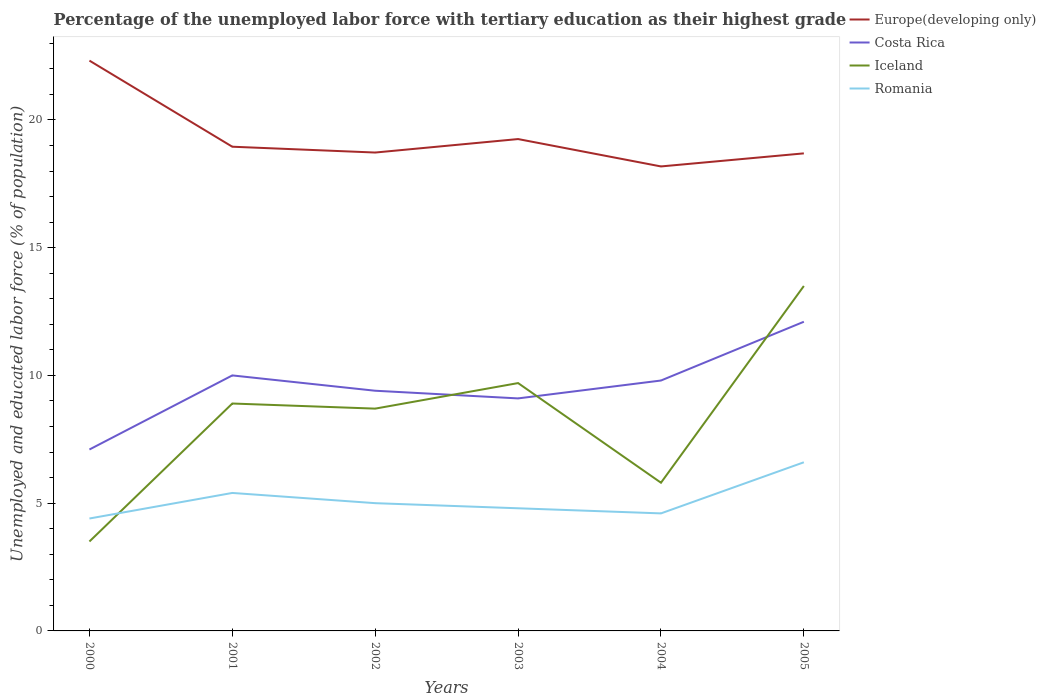How many different coloured lines are there?
Offer a very short reply. 4. Across all years, what is the maximum percentage of the unemployed labor force with tertiary education in Romania?
Your response must be concise. 4.4. What is the total percentage of the unemployed labor force with tertiary education in Iceland in the graph?
Your answer should be very brief. -1. What is the difference between the highest and the second highest percentage of the unemployed labor force with tertiary education in Romania?
Your answer should be very brief. 2.2. Is the percentage of the unemployed labor force with tertiary education in Europe(developing only) strictly greater than the percentage of the unemployed labor force with tertiary education in Romania over the years?
Provide a short and direct response. No. What is the difference between two consecutive major ticks on the Y-axis?
Keep it short and to the point. 5. How many legend labels are there?
Keep it short and to the point. 4. What is the title of the graph?
Ensure brevity in your answer.  Percentage of the unemployed labor force with tertiary education as their highest grade. Does "Cambodia" appear as one of the legend labels in the graph?
Provide a short and direct response. No. What is the label or title of the Y-axis?
Your answer should be very brief. Unemployed and educated labor force (% of population). What is the Unemployed and educated labor force (% of population) in Europe(developing only) in 2000?
Your answer should be compact. 22.32. What is the Unemployed and educated labor force (% of population) of Costa Rica in 2000?
Ensure brevity in your answer.  7.1. What is the Unemployed and educated labor force (% of population) in Romania in 2000?
Your answer should be very brief. 4.4. What is the Unemployed and educated labor force (% of population) in Europe(developing only) in 2001?
Ensure brevity in your answer.  18.95. What is the Unemployed and educated labor force (% of population) in Iceland in 2001?
Provide a short and direct response. 8.9. What is the Unemployed and educated labor force (% of population) of Romania in 2001?
Provide a succinct answer. 5.4. What is the Unemployed and educated labor force (% of population) in Europe(developing only) in 2002?
Ensure brevity in your answer.  18.72. What is the Unemployed and educated labor force (% of population) of Costa Rica in 2002?
Ensure brevity in your answer.  9.4. What is the Unemployed and educated labor force (% of population) in Iceland in 2002?
Provide a succinct answer. 8.7. What is the Unemployed and educated labor force (% of population) in Romania in 2002?
Ensure brevity in your answer.  5. What is the Unemployed and educated labor force (% of population) of Europe(developing only) in 2003?
Your response must be concise. 19.25. What is the Unemployed and educated labor force (% of population) of Costa Rica in 2003?
Offer a terse response. 9.1. What is the Unemployed and educated labor force (% of population) in Iceland in 2003?
Offer a very short reply. 9.7. What is the Unemployed and educated labor force (% of population) in Romania in 2003?
Offer a terse response. 4.8. What is the Unemployed and educated labor force (% of population) in Europe(developing only) in 2004?
Make the answer very short. 18.18. What is the Unemployed and educated labor force (% of population) in Costa Rica in 2004?
Offer a very short reply. 9.8. What is the Unemployed and educated labor force (% of population) in Iceland in 2004?
Keep it short and to the point. 5.8. What is the Unemployed and educated labor force (% of population) in Romania in 2004?
Your answer should be compact. 4.6. What is the Unemployed and educated labor force (% of population) in Europe(developing only) in 2005?
Provide a succinct answer. 18.69. What is the Unemployed and educated labor force (% of population) of Costa Rica in 2005?
Ensure brevity in your answer.  12.1. What is the Unemployed and educated labor force (% of population) in Iceland in 2005?
Offer a terse response. 13.5. What is the Unemployed and educated labor force (% of population) in Romania in 2005?
Your response must be concise. 6.6. Across all years, what is the maximum Unemployed and educated labor force (% of population) in Europe(developing only)?
Provide a short and direct response. 22.32. Across all years, what is the maximum Unemployed and educated labor force (% of population) of Costa Rica?
Your response must be concise. 12.1. Across all years, what is the maximum Unemployed and educated labor force (% of population) in Romania?
Provide a short and direct response. 6.6. Across all years, what is the minimum Unemployed and educated labor force (% of population) of Europe(developing only)?
Offer a terse response. 18.18. Across all years, what is the minimum Unemployed and educated labor force (% of population) in Costa Rica?
Your answer should be compact. 7.1. Across all years, what is the minimum Unemployed and educated labor force (% of population) in Romania?
Ensure brevity in your answer.  4.4. What is the total Unemployed and educated labor force (% of population) of Europe(developing only) in the graph?
Provide a succinct answer. 116.11. What is the total Unemployed and educated labor force (% of population) of Costa Rica in the graph?
Your response must be concise. 57.5. What is the total Unemployed and educated labor force (% of population) in Iceland in the graph?
Keep it short and to the point. 50.1. What is the total Unemployed and educated labor force (% of population) of Romania in the graph?
Make the answer very short. 30.8. What is the difference between the Unemployed and educated labor force (% of population) in Europe(developing only) in 2000 and that in 2001?
Provide a short and direct response. 3.37. What is the difference between the Unemployed and educated labor force (% of population) of Costa Rica in 2000 and that in 2001?
Give a very brief answer. -2.9. What is the difference between the Unemployed and educated labor force (% of population) of Romania in 2000 and that in 2001?
Your answer should be compact. -1. What is the difference between the Unemployed and educated labor force (% of population) in Europe(developing only) in 2000 and that in 2002?
Provide a short and direct response. 3.6. What is the difference between the Unemployed and educated labor force (% of population) in Costa Rica in 2000 and that in 2002?
Provide a succinct answer. -2.3. What is the difference between the Unemployed and educated labor force (% of population) of Europe(developing only) in 2000 and that in 2003?
Provide a short and direct response. 3.07. What is the difference between the Unemployed and educated labor force (% of population) of Iceland in 2000 and that in 2003?
Give a very brief answer. -6.2. What is the difference between the Unemployed and educated labor force (% of population) in Europe(developing only) in 2000 and that in 2004?
Give a very brief answer. 4.14. What is the difference between the Unemployed and educated labor force (% of population) in Costa Rica in 2000 and that in 2004?
Offer a terse response. -2.7. What is the difference between the Unemployed and educated labor force (% of population) of Romania in 2000 and that in 2004?
Your answer should be compact. -0.2. What is the difference between the Unemployed and educated labor force (% of population) in Europe(developing only) in 2000 and that in 2005?
Provide a short and direct response. 3.63. What is the difference between the Unemployed and educated labor force (% of population) of Costa Rica in 2000 and that in 2005?
Provide a short and direct response. -5. What is the difference between the Unemployed and educated labor force (% of population) of Iceland in 2000 and that in 2005?
Give a very brief answer. -10. What is the difference between the Unemployed and educated labor force (% of population) in Romania in 2000 and that in 2005?
Offer a terse response. -2.2. What is the difference between the Unemployed and educated labor force (% of population) of Europe(developing only) in 2001 and that in 2002?
Your answer should be very brief. 0.23. What is the difference between the Unemployed and educated labor force (% of population) in Costa Rica in 2001 and that in 2002?
Give a very brief answer. 0.6. What is the difference between the Unemployed and educated labor force (% of population) of Iceland in 2001 and that in 2002?
Your response must be concise. 0.2. What is the difference between the Unemployed and educated labor force (% of population) in Romania in 2001 and that in 2002?
Your answer should be very brief. 0.4. What is the difference between the Unemployed and educated labor force (% of population) in Europe(developing only) in 2001 and that in 2003?
Offer a very short reply. -0.3. What is the difference between the Unemployed and educated labor force (% of population) of Costa Rica in 2001 and that in 2003?
Your answer should be very brief. 0.9. What is the difference between the Unemployed and educated labor force (% of population) in Romania in 2001 and that in 2003?
Your answer should be very brief. 0.6. What is the difference between the Unemployed and educated labor force (% of population) of Europe(developing only) in 2001 and that in 2004?
Your answer should be compact. 0.77. What is the difference between the Unemployed and educated labor force (% of population) in Costa Rica in 2001 and that in 2004?
Provide a succinct answer. 0.2. What is the difference between the Unemployed and educated labor force (% of population) in Iceland in 2001 and that in 2004?
Make the answer very short. 3.1. What is the difference between the Unemployed and educated labor force (% of population) in Romania in 2001 and that in 2004?
Your response must be concise. 0.8. What is the difference between the Unemployed and educated labor force (% of population) of Europe(developing only) in 2001 and that in 2005?
Provide a short and direct response. 0.26. What is the difference between the Unemployed and educated labor force (% of population) in Iceland in 2001 and that in 2005?
Your answer should be very brief. -4.6. What is the difference between the Unemployed and educated labor force (% of population) in Romania in 2001 and that in 2005?
Your answer should be compact. -1.2. What is the difference between the Unemployed and educated labor force (% of population) of Europe(developing only) in 2002 and that in 2003?
Keep it short and to the point. -0.53. What is the difference between the Unemployed and educated labor force (% of population) in Europe(developing only) in 2002 and that in 2004?
Keep it short and to the point. 0.54. What is the difference between the Unemployed and educated labor force (% of population) of Europe(developing only) in 2002 and that in 2005?
Offer a terse response. 0.03. What is the difference between the Unemployed and educated labor force (% of population) of Iceland in 2002 and that in 2005?
Your answer should be compact. -4.8. What is the difference between the Unemployed and educated labor force (% of population) of Romania in 2002 and that in 2005?
Your answer should be very brief. -1.6. What is the difference between the Unemployed and educated labor force (% of population) of Europe(developing only) in 2003 and that in 2004?
Provide a short and direct response. 1.07. What is the difference between the Unemployed and educated labor force (% of population) of Costa Rica in 2003 and that in 2004?
Your answer should be very brief. -0.7. What is the difference between the Unemployed and educated labor force (% of population) of Iceland in 2003 and that in 2004?
Ensure brevity in your answer.  3.9. What is the difference between the Unemployed and educated labor force (% of population) in Europe(developing only) in 2003 and that in 2005?
Provide a short and direct response. 0.56. What is the difference between the Unemployed and educated labor force (% of population) of Costa Rica in 2003 and that in 2005?
Provide a succinct answer. -3. What is the difference between the Unemployed and educated labor force (% of population) in Romania in 2003 and that in 2005?
Your answer should be compact. -1.8. What is the difference between the Unemployed and educated labor force (% of population) of Europe(developing only) in 2004 and that in 2005?
Give a very brief answer. -0.51. What is the difference between the Unemployed and educated labor force (% of population) of Iceland in 2004 and that in 2005?
Provide a short and direct response. -7.7. What is the difference between the Unemployed and educated labor force (% of population) in Europe(developing only) in 2000 and the Unemployed and educated labor force (% of population) in Costa Rica in 2001?
Give a very brief answer. 12.32. What is the difference between the Unemployed and educated labor force (% of population) of Europe(developing only) in 2000 and the Unemployed and educated labor force (% of population) of Iceland in 2001?
Provide a short and direct response. 13.42. What is the difference between the Unemployed and educated labor force (% of population) in Europe(developing only) in 2000 and the Unemployed and educated labor force (% of population) in Romania in 2001?
Offer a very short reply. 16.92. What is the difference between the Unemployed and educated labor force (% of population) of Costa Rica in 2000 and the Unemployed and educated labor force (% of population) of Romania in 2001?
Your answer should be compact. 1.7. What is the difference between the Unemployed and educated labor force (% of population) in Europe(developing only) in 2000 and the Unemployed and educated labor force (% of population) in Costa Rica in 2002?
Offer a very short reply. 12.92. What is the difference between the Unemployed and educated labor force (% of population) in Europe(developing only) in 2000 and the Unemployed and educated labor force (% of population) in Iceland in 2002?
Offer a very short reply. 13.62. What is the difference between the Unemployed and educated labor force (% of population) of Europe(developing only) in 2000 and the Unemployed and educated labor force (% of population) of Romania in 2002?
Provide a succinct answer. 17.32. What is the difference between the Unemployed and educated labor force (% of population) in Costa Rica in 2000 and the Unemployed and educated labor force (% of population) in Iceland in 2002?
Your answer should be compact. -1.6. What is the difference between the Unemployed and educated labor force (% of population) in Costa Rica in 2000 and the Unemployed and educated labor force (% of population) in Romania in 2002?
Your answer should be very brief. 2.1. What is the difference between the Unemployed and educated labor force (% of population) of Iceland in 2000 and the Unemployed and educated labor force (% of population) of Romania in 2002?
Offer a terse response. -1.5. What is the difference between the Unemployed and educated labor force (% of population) in Europe(developing only) in 2000 and the Unemployed and educated labor force (% of population) in Costa Rica in 2003?
Offer a terse response. 13.22. What is the difference between the Unemployed and educated labor force (% of population) in Europe(developing only) in 2000 and the Unemployed and educated labor force (% of population) in Iceland in 2003?
Offer a very short reply. 12.62. What is the difference between the Unemployed and educated labor force (% of population) in Europe(developing only) in 2000 and the Unemployed and educated labor force (% of population) in Romania in 2003?
Make the answer very short. 17.52. What is the difference between the Unemployed and educated labor force (% of population) in Costa Rica in 2000 and the Unemployed and educated labor force (% of population) in Iceland in 2003?
Provide a short and direct response. -2.6. What is the difference between the Unemployed and educated labor force (% of population) of Costa Rica in 2000 and the Unemployed and educated labor force (% of population) of Romania in 2003?
Your answer should be very brief. 2.3. What is the difference between the Unemployed and educated labor force (% of population) in Iceland in 2000 and the Unemployed and educated labor force (% of population) in Romania in 2003?
Your response must be concise. -1.3. What is the difference between the Unemployed and educated labor force (% of population) in Europe(developing only) in 2000 and the Unemployed and educated labor force (% of population) in Costa Rica in 2004?
Your answer should be compact. 12.52. What is the difference between the Unemployed and educated labor force (% of population) of Europe(developing only) in 2000 and the Unemployed and educated labor force (% of population) of Iceland in 2004?
Keep it short and to the point. 16.52. What is the difference between the Unemployed and educated labor force (% of population) of Europe(developing only) in 2000 and the Unemployed and educated labor force (% of population) of Romania in 2004?
Give a very brief answer. 17.72. What is the difference between the Unemployed and educated labor force (% of population) in Costa Rica in 2000 and the Unemployed and educated labor force (% of population) in Iceland in 2004?
Ensure brevity in your answer.  1.3. What is the difference between the Unemployed and educated labor force (% of population) of Iceland in 2000 and the Unemployed and educated labor force (% of population) of Romania in 2004?
Ensure brevity in your answer.  -1.1. What is the difference between the Unemployed and educated labor force (% of population) in Europe(developing only) in 2000 and the Unemployed and educated labor force (% of population) in Costa Rica in 2005?
Provide a short and direct response. 10.22. What is the difference between the Unemployed and educated labor force (% of population) in Europe(developing only) in 2000 and the Unemployed and educated labor force (% of population) in Iceland in 2005?
Make the answer very short. 8.82. What is the difference between the Unemployed and educated labor force (% of population) of Europe(developing only) in 2000 and the Unemployed and educated labor force (% of population) of Romania in 2005?
Offer a terse response. 15.72. What is the difference between the Unemployed and educated labor force (% of population) in Costa Rica in 2000 and the Unemployed and educated labor force (% of population) in Iceland in 2005?
Your answer should be compact. -6.4. What is the difference between the Unemployed and educated labor force (% of population) in Iceland in 2000 and the Unemployed and educated labor force (% of population) in Romania in 2005?
Give a very brief answer. -3.1. What is the difference between the Unemployed and educated labor force (% of population) in Europe(developing only) in 2001 and the Unemployed and educated labor force (% of population) in Costa Rica in 2002?
Provide a short and direct response. 9.55. What is the difference between the Unemployed and educated labor force (% of population) in Europe(developing only) in 2001 and the Unemployed and educated labor force (% of population) in Iceland in 2002?
Offer a very short reply. 10.25. What is the difference between the Unemployed and educated labor force (% of population) in Europe(developing only) in 2001 and the Unemployed and educated labor force (% of population) in Romania in 2002?
Provide a succinct answer. 13.95. What is the difference between the Unemployed and educated labor force (% of population) of Costa Rica in 2001 and the Unemployed and educated labor force (% of population) of Iceland in 2002?
Offer a terse response. 1.3. What is the difference between the Unemployed and educated labor force (% of population) of Costa Rica in 2001 and the Unemployed and educated labor force (% of population) of Romania in 2002?
Keep it short and to the point. 5. What is the difference between the Unemployed and educated labor force (% of population) in Europe(developing only) in 2001 and the Unemployed and educated labor force (% of population) in Costa Rica in 2003?
Make the answer very short. 9.85. What is the difference between the Unemployed and educated labor force (% of population) in Europe(developing only) in 2001 and the Unemployed and educated labor force (% of population) in Iceland in 2003?
Ensure brevity in your answer.  9.25. What is the difference between the Unemployed and educated labor force (% of population) in Europe(developing only) in 2001 and the Unemployed and educated labor force (% of population) in Romania in 2003?
Your answer should be very brief. 14.15. What is the difference between the Unemployed and educated labor force (% of population) of Europe(developing only) in 2001 and the Unemployed and educated labor force (% of population) of Costa Rica in 2004?
Give a very brief answer. 9.15. What is the difference between the Unemployed and educated labor force (% of population) of Europe(developing only) in 2001 and the Unemployed and educated labor force (% of population) of Iceland in 2004?
Your response must be concise. 13.15. What is the difference between the Unemployed and educated labor force (% of population) of Europe(developing only) in 2001 and the Unemployed and educated labor force (% of population) of Romania in 2004?
Provide a short and direct response. 14.35. What is the difference between the Unemployed and educated labor force (% of population) of Costa Rica in 2001 and the Unemployed and educated labor force (% of population) of Iceland in 2004?
Provide a succinct answer. 4.2. What is the difference between the Unemployed and educated labor force (% of population) in Costa Rica in 2001 and the Unemployed and educated labor force (% of population) in Romania in 2004?
Your answer should be very brief. 5.4. What is the difference between the Unemployed and educated labor force (% of population) of Europe(developing only) in 2001 and the Unemployed and educated labor force (% of population) of Costa Rica in 2005?
Keep it short and to the point. 6.85. What is the difference between the Unemployed and educated labor force (% of population) in Europe(developing only) in 2001 and the Unemployed and educated labor force (% of population) in Iceland in 2005?
Your response must be concise. 5.45. What is the difference between the Unemployed and educated labor force (% of population) of Europe(developing only) in 2001 and the Unemployed and educated labor force (% of population) of Romania in 2005?
Offer a very short reply. 12.35. What is the difference between the Unemployed and educated labor force (% of population) in Iceland in 2001 and the Unemployed and educated labor force (% of population) in Romania in 2005?
Offer a terse response. 2.3. What is the difference between the Unemployed and educated labor force (% of population) of Europe(developing only) in 2002 and the Unemployed and educated labor force (% of population) of Costa Rica in 2003?
Your response must be concise. 9.62. What is the difference between the Unemployed and educated labor force (% of population) of Europe(developing only) in 2002 and the Unemployed and educated labor force (% of population) of Iceland in 2003?
Ensure brevity in your answer.  9.02. What is the difference between the Unemployed and educated labor force (% of population) in Europe(developing only) in 2002 and the Unemployed and educated labor force (% of population) in Romania in 2003?
Your response must be concise. 13.92. What is the difference between the Unemployed and educated labor force (% of population) in Costa Rica in 2002 and the Unemployed and educated labor force (% of population) in Iceland in 2003?
Offer a very short reply. -0.3. What is the difference between the Unemployed and educated labor force (% of population) of Costa Rica in 2002 and the Unemployed and educated labor force (% of population) of Romania in 2003?
Your response must be concise. 4.6. What is the difference between the Unemployed and educated labor force (% of population) in Europe(developing only) in 2002 and the Unemployed and educated labor force (% of population) in Costa Rica in 2004?
Keep it short and to the point. 8.92. What is the difference between the Unemployed and educated labor force (% of population) in Europe(developing only) in 2002 and the Unemployed and educated labor force (% of population) in Iceland in 2004?
Offer a terse response. 12.92. What is the difference between the Unemployed and educated labor force (% of population) of Europe(developing only) in 2002 and the Unemployed and educated labor force (% of population) of Romania in 2004?
Make the answer very short. 14.12. What is the difference between the Unemployed and educated labor force (% of population) in Costa Rica in 2002 and the Unemployed and educated labor force (% of population) in Iceland in 2004?
Keep it short and to the point. 3.6. What is the difference between the Unemployed and educated labor force (% of population) in Costa Rica in 2002 and the Unemployed and educated labor force (% of population) in Romania in 2004?
Provide a short and direct response. 4.8. What is the difference between the Unemployed and educated labor force (% of population) of Iceland in 2002 and the Unemployed and educated labor force (% of population) of Romania in 2004?
Keep it short and to the point. 4.1. What is the difference between the Unemployed and educated labor force (% of population) in Europe(developing only) in 2002 and the Unemployed and educated labor force (% of population) in Costa Rica in 2005?
Your answer should be very brief. 6.62. What is the difference between the Unemployed and educated labor force (% of population) of Europe(developing only) in 2002 and the Unemployed and educated labor force (% of population) of Iceland in 2005?
Provide a succinct answer. 5.22. What is the difference between the Unemployed and educated labor force (% of population) of Europe(developing only) in 2002 and the Unemployed and educated labor force (% of population) of Romania in 2005?
Provide a short and direct response. 12.12. What is the difference between the Unemployed and educated labor force (% of population) in Costa Rica in 2002 and the Unemployed and educated labor force (% of population) in Iceland in 2005?
Your answer should be compact. -4.1. What is the difference between the Unemployed and educated labor force (% of population) of Iceland in 2002 and the Unemployed and educated labor force (% of population) of Romania in 2005?
Offer a terse response. 2.1. What is the difference between the Unemployed and educated labor force (% of population) in Europe(developing only) in 2003 and the Unemployed and educated labor force (% of population) in Costa Rica in 2004?
Provide a short and direct response. 9.45. What is the difference between the Unemployed and educated labor force (% of population) of Europe(developing only) in 2003 and the Unemployed and educated labor force (% of population) of Iceland in 2004?
Your answer should be compact. 13.45. What is the difference between the Unemployed and educated labor force (% of population) of Europe(developing only) in 2003 and the Unemployed and educated labor force (% of population) of Romania in 2004?
Provide a succinct answer. 14.65. What is the difference between the Unemployed and educated labor force (% of population) of Costa Rica in 2003 and the Unemployed and educated labor force (% of population) of Iceland in 2004?
Your response must be concise. 3.3. What is the difference between the Unemployed and educated labor force (% of population) in Iceland in 2003 and the Unemployed and educated labor force (% of population) in Romania in 2004?
Your answer should be compact. 5.1. What is the difference between the Unemployed and educated labor force (% of population) of Europe(developing only) in 2003 and the Unemployed and educated labor force (% of population) of Costa Rica in 2005?
Provide a short and direct response. 7.15. What is the difference between the Unemployed and educated labor force (% of population) of Europe(developing only) in 2003 and the Unemployed and educated labor force (% of population) of Iceland in 2005?
Your answer should be compact. 5.75. What is the difference between the Unemployed and educated labor force (% of population) in Europe(developing only) in 2003 and the Unemployed and educated labor force (% of population) in Romania in 2005?
Provide a succinct answer. 12.65. What is the difference between the Unemployed and educated labor force (% of population) in Costa Rica in 2003 and the Unemployed and educated labor force (% of population) in Romania in 2005?
Your answer should be very brief. 2.5. What is the difference between the Unemployed and educated labor force (% of population) in Iceland in 2003 and the Unemployed and educated labor force (% of population) in Romania in 2005?
Offer a terse response. 3.1. What is the difference between the Unemployed and educated labor force (% of population) of Europe(developing only) in 2004 and the Unemployed and educated labor force (% of population) of Costa Rica in 2005?
Provide a succinct answer. 6.08. What is the difference between the Unemployed and educated labor force (% of population) of Europe(developing only) in 2004 and the Unemployed and educated labor force (% of population) of Iceland in 2005?
Give a very brief answer. 4.68. What is the difference between the Unemployed and educated labor force (% of population) in Europe(developing only) in 2004 and the Unemployed and educated labor force (% of population) in Romania in 2005?
Your answer should be very brief. 11.58. What is the average Unemployed and educated labor force (% of population) of Europe(developing only) per year?
Keep it short and to the point. 19.35. What is the average Unemployed and educated labor force (% of population) of Costa Rica per year?
Ensure brevity in your answer.  9.58. What is the average Unemployed and educated labor force (% of population) in Iceland per year?
Your answer should be compact. 8.35. What is the average Unemployed and educated labor force (% of population) in Romania per year?
Keep it short and to the point. 5.13. In the year 2000, what is the difference between the Unemployed and educated labor force (% of population) of Europe(developing only) and Unemployed and educated labor force (% of population) of Costa Rica?
Offer a terse response. 15.22. In the year 2000, what is the difference between the Unemployed and educated labor force (% of population) of Europe(developing only) and Unemployed and educated labor force (% of population) of Iceland?
Your answer should be very brief. 18.82. In the year 2000, what is the difference between the Unemployed and educated labor force (% of population) of Europe(developing only) and Unemployed and educated labor force (% of population) of Romania?
Ensure brevity in your answer.  17.92. In the year 2000, what is the difference between the Unemployed and educated labor force (% of population) of Costa Rica and Unemployed and educated labor force (% of population) of Iceland?
Offer a very short reply. 3.6. In the year 2001, what is the difference between the Unemployed and educated labor force (% of population) of Europe(developing only) and Unemployed and educated labor force (% of population) of Costa Rica?
Your answer should be very brief. 8.95. In the year 2001, what is the difference between the Unemployed and educated labor force (% of population) of Europe(developing only) and Unemployed and educated labor force (% of population) of Iceland?
Offer a terse response. 10.05. In the year 2001, what is the difference between the Unemployed and educated labor force (% of population) in Europe(developing only) and Unemployed and educated labor force (% of population) in Romania?
Provide a succinct answer. 13.55. In the year 2001, what is the difference between the Unemployed and educated labor force (% of population) of Costa Rica and Unemployed and educated labor force (% of population) of Iceland?
Your answer should be very brief. 1.1. In the year 2002, what is the difference between the Unemployed and educated labor force (% of population) in Europe(developing only) and Unemployed and educated labor force (% of population) in Costa Rica?
Make the answer very short. 9.32. In the year 2002, what is the difference between the Unemployed and educated labor force (% of population) of Europe(developing only) and Unemployed and educated labor force (% of population) of Iceland?
Give a very brief answer. 10.02. In the year 2002, what is the difference between the Unemployed and educated labor force (% of population) in Europe(developing only) and Unemployed and educated labor force (% of population) in Romania?
Ensure brevity in your answer.  13.72. In the year 2002, what is the difference between the Unemployed and educated labor force (% of population) of Costa Rica and Unemployed and educated labor force (% of population) of Iceland?
Provide a succinct answer. 0.7. In the year 2003, what is the difference between the Unemployed and educated labor force (% of population) in Europe(developing only) and Unemployed and educated labor force (% of population) in Costa Rica?
Offer a very short reply. 10.15. In the year 2003, what is the difference between the Unemployed and educated labor force (% of population) in Europe(developing only) and Unemployed and educated labor force (% of population) in Iceland?
Provide a short and direct response. 9.55. In the year 2003, what is the difference between the Unemployed and educated labor force (% of population) of Europe(developing only) and Unemployed and educated labor force (% of population) of Romania?
Offer a terse response. 14.45. In the year 2003, what is the difference between the Unemployed and educated labor force (% of population) of Costa Rica and Unemployed and educated labor force (% of population) of Romania?
Ensure brevity in your answer.  4.3. In the year 2003, what is the difference between the Unemployed and educated labor force (% of population) of Iceland and Unemployed and educated labor force (% of population) of Romania?
Provide a succinct answer. 4.9. In the year 2004, what is the difference between the Unemployed and educated labor force (% of population) in Europe(developing only) and Unemployed and educated labor force (% of population) in Costa Rica?
Your answer should be very brief. 8.38. In the year 2004, what is the difference between the Unemployed and educated labor force (% of population) in Europe(developing only) and Unemployed and educated labor force (% of population) in Iceland?
Offer a very short reply. 12.38. In the year 2004, what is the difference between the Unemployed and educated labor force (% of population) in Europe(developing only) and Unemployed and educated labor force (% of population) in Romania?
Provide a short and direct response. 13.58. In the year 2004, what is the difference between the Unemployed and educated labor force (% of population) in Costa Rica and Unemployed and educated labor force (% of population) in Romania?
Offer a terse response. 5.2. In the year 2004, what is the difference between the Unemployed and educated labor force (% of population) in Iceland and Unemployed and educated labor force (% of population) in Romania?
Provide a short and direct response. 1.2. In the year 2005, what is the difference between the Unemployed and educated labor force (% of population) in Europe(developing only) and Unemployed and educated labor force (% of population) in Costa Rica?
Offer a very short reply. 6.59. In the year 2005, what is the difference between the Unemployed and educated labor force (% of population) of Europe(developing only) and Unemployed and educated labor force (% of population) of Iceland?
Keep it short and to the point. 5.19. In the year 2005, what is the difference between the Unemployed and educated labor force (% of population) in Europe(developing only) and Unemployed and educated labor force (% of population) in Romania?
Provide a short and direct response. 12.09. In the year 2005, what is the difference between the Unemployed and educated labor force (% of population) of Costa Rica and Unemployed and educated labor force (% of population) of Iceland?
Give a very brief answer. -1.4. In the year 2005, what is the difference between the Unemployed and educated labor force (% of population) of Costa Rica and Unemployed and educated labor force (% of population) of Romania?
Make the answer very short. 5.5. In the year 2005, what is the difference between the Unemployed and educated labor force (% of population) of Iceland and Unemployed and educated labor force (% of population) of Romania?
Your answer should be compact. 6.9. What is the ratio of the Unemployed and educated labor force (% of population) in Europe(developing only) in 2000 to that in 2001?
Offer a very short reply. 1.18. What is the ratio of the Unemployed and educated labor force (% of population) in Costa Rica in 2000 to that in 2001?
Give a very brief answer. 0.71. What is the ratio of the Unemployed and educated labor force (% of population) in Iceland in 2000 to that in 2001?
Give a very brief answer. 0.39. What is the ratio of the Unemployed and educated labor force (% of population) of Romania in 2000 to that in 2001?
Give a very brief answer. 0.81. What is the ratio of the Unemployed and educated labor force (% of population) in Europe(developing only) in 2000 to that in 2002?
Your answer should be compact. 1.19. What is the ratio of the Unemployed and educated labor force (% of population) of Costa Rica in 2000 to that in 2002?
Your response must be concise. 0.76. What is the ratio of the Unemployed and educated labor force (% of population) of Iceland in 2000 to that in 2002?
Provide a succinct answer. 0.4. What is the ratio of the Unemployed and educated labor force (% of population) of Europe(developing only) in 2000 to that in 2003?
Ensure brevity in your answer.  1.16. What is the ratio of the Unemployed and educated labor force (% of population) of Costa Rica in 2000 to that in 2003?
Offer a very short reply. 0.78. What is the ratio of the Unemployed and educated labor force (% of population) of Iceland in 2000 to that in 2003?
Provide a short and direct response. 0.36. What is the ratio of the Unemployed and educated labor force (% of population) of Europe(developing only) in 2000 to that in 2004?
Your response must be concise. 1.23. What is the ratio of the Unemployed and educated labor force (% of population) in Costa Rica in 2000 to that in 2004?
Make the answer very short. 0.72. What is the ratio of the Unemployed and educated labor force (% of population) in Iceland in 2000 to that in 2004?
Make the answer very short. 0.6. What is the ratio of the Unemployed and educated labor force (% of population) of Romania in 2000 to that in 2004?
Keep it short and to the point. 0.96. What is the ratio of the Unemployed and educated labor force (% of population) of Europe(developing only) in 2000 to that in 2005?
Offer a terse response. 1.19. What is the ratio of the Unemployed and educated labor force (% of population) in Costa Rica in 2000 to that in 2005?
Keep it short and to the point. 0.59. What is the ratio of the Unemployed and educated labor force (% of population) of Iceland in 2000 to that in 2005?
Offer a very short reply. 0.26. What is the ratio of the Unemployed and educated labor force (% of population) of Europe(developing only) in 2001 to that in 2002?
Your answer should be compact. 1.01. What is the ratio of the Unemployed and educated labor force (% of population) of Costa Rica in 2001 to that in 2002?
Keep it short and to the point. 1.06. What is the ratio of the Unemployed and educated labor force (% of population) of Europe(developing only) in 2001 to that in 2003?
Provide a succinct answer. 0.98. What is the ratio of the Unemployed and educated labor force (% of population) in Costa Rica in 2001 to that in 2003?
Keep it short and to the point. 1.1. What is the ratio of the Unemployed and educated labor force (% of population) in Iceland in 2001 to that in 2003?
Ensure brevity in your answer.  0.92. What is the ratio of the Unemployed and educated labor force (% of population) of Romania in 2001 to that in 2003?
Provide a succinct answer. 1.12. What is the ratio of the Unemployed and educated labor force (% of population) in Europe(developing only) in 2001 to that in 2004?
Provide a succinct answer. 1.04. What is the ratio of the Unemployed and educated labor force (% of population) in Costa Rica in 2001 to that in 2004?
Your response must be concise. 1.02. What is the ratio of the Unemployed and educated labor force (% of population) in Iceland in 2001 to that in 2004?
Ensure brevity in your answer.  1.53. What is the ratio of the Unemployed and educated labor force (% of population) in Romania in 2001 to that in 2004?
Keep it short and to the point. 1.17. What is the ratio of the Unemployed and educated labor force (% of population) in Europe(developing only) in 2001 to that in 2005?
Your response must be concise. 1.01. What is the ratio of the Unemployed and educated labor force (% of population) in Costa Rica in 2001 to that in 2005?
Offer a terse response. 0.83. What is the ratio of the Unemployed and educated labor force (% of population) of Iceland in 2001 to that in 2005?
Your answer should be compact. 0.66. What is the ratio of the Unemployed and educated labor force (% of population) of Romania in 2001 to that in 2005?
Make the answer very short. 0.82. What is the ratio of the Unemployed and educated labor force (% of population) in Europe(developing only) in 2002 to that in 2003?
Your answer should be compact. 0.97. What is the ratio of the Unemployed and educated labor force (% of population) of Costa Rica in 2002 to that in 2003?
Keep it short and to the point. 1.03. What is the ratio of the Unemployed and educated labor force (% of population) in Iceland in 2002 to that in 2003?
Make the answer very short. 0.9. What is the ratio of the Unemployed and educated labor force (% of population) in Romania in 2002 to that in 2003?
Offer a very short reply. 1.04. What is the ratio of the Unemployed and educated labor force (% of population) of Europe(developing only) in 2002 to that in 2004?
Give a very brief answer. 1.03. What is the ratio of the Unemployed and educated labor force (% of population) of Costa Rica in 2002 to that in 2004?
Your response must be concise. 0.96. What is the ratio of the Unemployed and educated labor force (% of population) of Romania in 2002 to that in 2004?
Offer a very short reply. 1.09. What is the ratio of the Unemployed and educated labor force (% of population) in Costa Rica in 2002 to that in 2005?
Your response must be concise. 0.78. What is the ratio of the Unemployed and educated labor force (% of population) of Iceland in 2002 to that in 2005?
Offer a very short reply. 0.64. What is the ratio of the Unemployed and educated labor force (% of population) in Romania in 2002 to that in 2005?
Keep it short and to the point. 0.76. What is the ratio of the Unemployed and educated labor force (% of population) in Europe(developing only) in 2003 to that in 2004?
Your response must be concise. 1.06. What is the ratio of the Unemployed and educated labor force (% of population) of Costa Rica in 2003 to that in 2004?
Provide a succinct answer. 0.93. What is the ratio of the Unemployed and educated labor force (% of population) of Iceland in 2003 to that in 2004?
Provide a short and direct response. 1.67. What is the ratio of the Unemployed and educated labor force (% of population) in Romania in 2003 to that in 2004?
Your answer should be very brief. 1.04. What is the ratio of the Unemployed and educated labor force (% of population) of Costa Rica in 2003 to that in 2005?
Your response must be concise. 0.75. What is the ratio of the Unemployed and educated labor force (% of population) of Iceland in 2003 to that in 2005?
Offer a terse response. 0.72. What is the ratio of the Unemployed and educated labor force (% of population) in Romania in 2003 to that in 2005?
Give a very brief answer. 0.73. What is the ratio of the Unemployed and educated labor force (% of population) in Europe(developing only) in 2004 to that in 2005?
Ensure brevity in your answer.  0.97. What is the ratio of the Unemployed and educated labor force (% of population) of Costa Rica in 2004 to that in 2005?
Offer a very short reply. 0.81. What is the ratio of the Unemployed and educated labor force (% of population) in Iceland in 2004 to that in 2005?
Make the answer very short. 0.43. What is the ratio of the Unemployed and educated labor force (% of population) of Romania in 2004 to that in 2005?
Your answer should be compact. 0.7. What is the difference between the highest and the second highest Unemployed and educated labor force (% of population) of Europe(developing only)?
Offer a terse response. 3.07. What is the difference between the highest and the second highest Unemployed and educated labor force (% of population) of Costa Rica?
Your response must be concise. 2.1. What is the difference between the highest and the second highest Unemployed and educated labor force (% of population) in Romania?
Ensure brevity in your answer.  1.2. What is the difference between the highest and the lowest Unemployed and educated labor force (% of population) in Europe(developing only)?
Your answer should be very brief. 4.14. What is the difference between the highest and the lowest Unemployed and educated labor force (% of population) of Costa Rica?
Give a very brief answer. 5. What is the difference between the highest and the lowest Unemployed and educated labor force (% of population) of Iceland?
Ensure brevity in your answer.  10. 